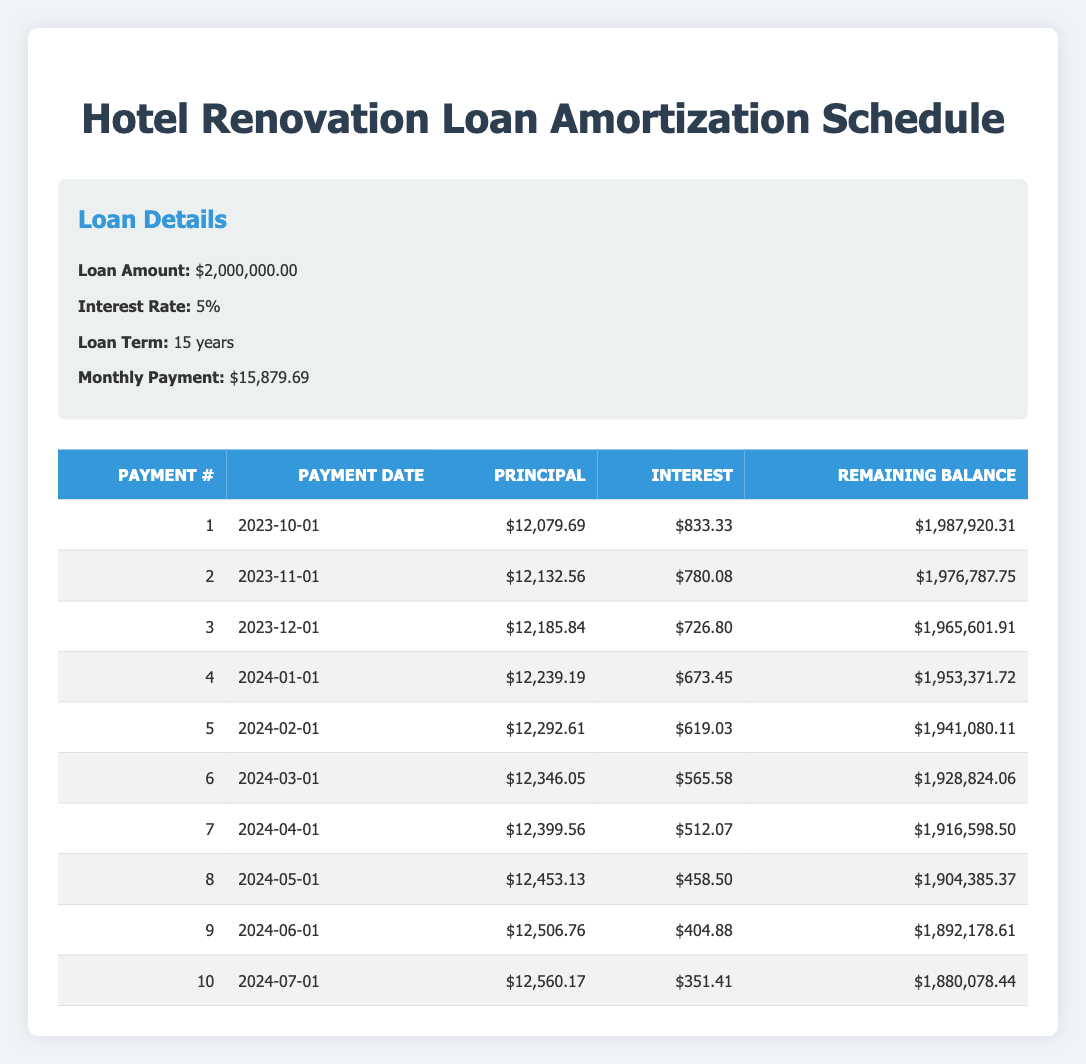What is the total amount paid in the first two payments? The first payment is 15879.69 and the second payment is also 15879.69. To find the total, simply add these two amounts together: 15879.69 + 15879.69 = 31759.38
Answer: 31759.38 What is the remaining balance after the third payment? The third payment's remaining balance is found in the table: it shows the remaining balance after the third payment is 1965601.91
Answer: 1965601.91 Is the interest payment decreasing with each payment? By examining the interest payments for the first three months, we see payments of 833.33, 780.08, and 726.80. Each month shows a decrease, indicating that the interest payment is indeed decreasing.
Answer: Yes What is the principal amount paid in the fifth month? Referring to the fifth payment in the table, the principal payment recorded is 12292.61.
Answer: 12292.61 How much total interest is paid in the first four payments? We sum the interest payments from the first four payments: 833.33 + 780.08 + 726.80 + 673.45 = 3013.66. This total gives the amount of interest paid over those four months.
Answer: 3013.66 What is the difference in the principal payments between the first and the tenth payment? The principal payment for the first payment is 12079.69, and for the tenth payment, it is 12560.17. The difference can be calculated by subtracting the first from the tenth: 12560.17 - 12079.69 = 480.48.
Answer: 480.48 What is the average principal payment for the first three months? To find the average, we add the principal payments for the first three payments: 12079.69 + 12132.56 + 12185.84 = 36398.09 and then divide by 3: 36398.09 / 3 = 12132.69667. Rounding gives approximately 12132.70.
Answer: 12132.70 What is the highest remaining balance recorded after the first four payments? The remaining balances after the first four payments are: 1987920.31, 1976787.75, 1965601.91, and 1953371.72. The highest remaining balance is 1987920.31.
Answer: 1987920.31 Is the total monthly payment consistent across all months? The table shows that the monthly payment is consistently 15879.69 for all entries.
Answer: Yes 